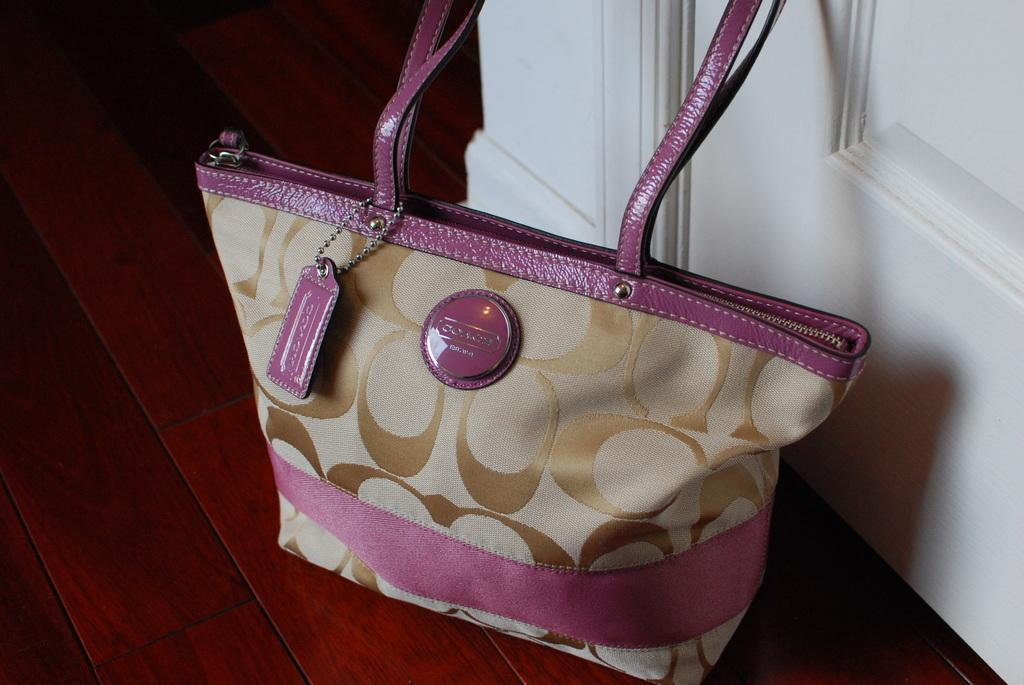What object can be seen in the image? There is a handbag in the image. Where is the handbag located? The handbag is on a table. Is there a basin filled with water near the handbag in the image? No, there is no basin or water present in the image. 